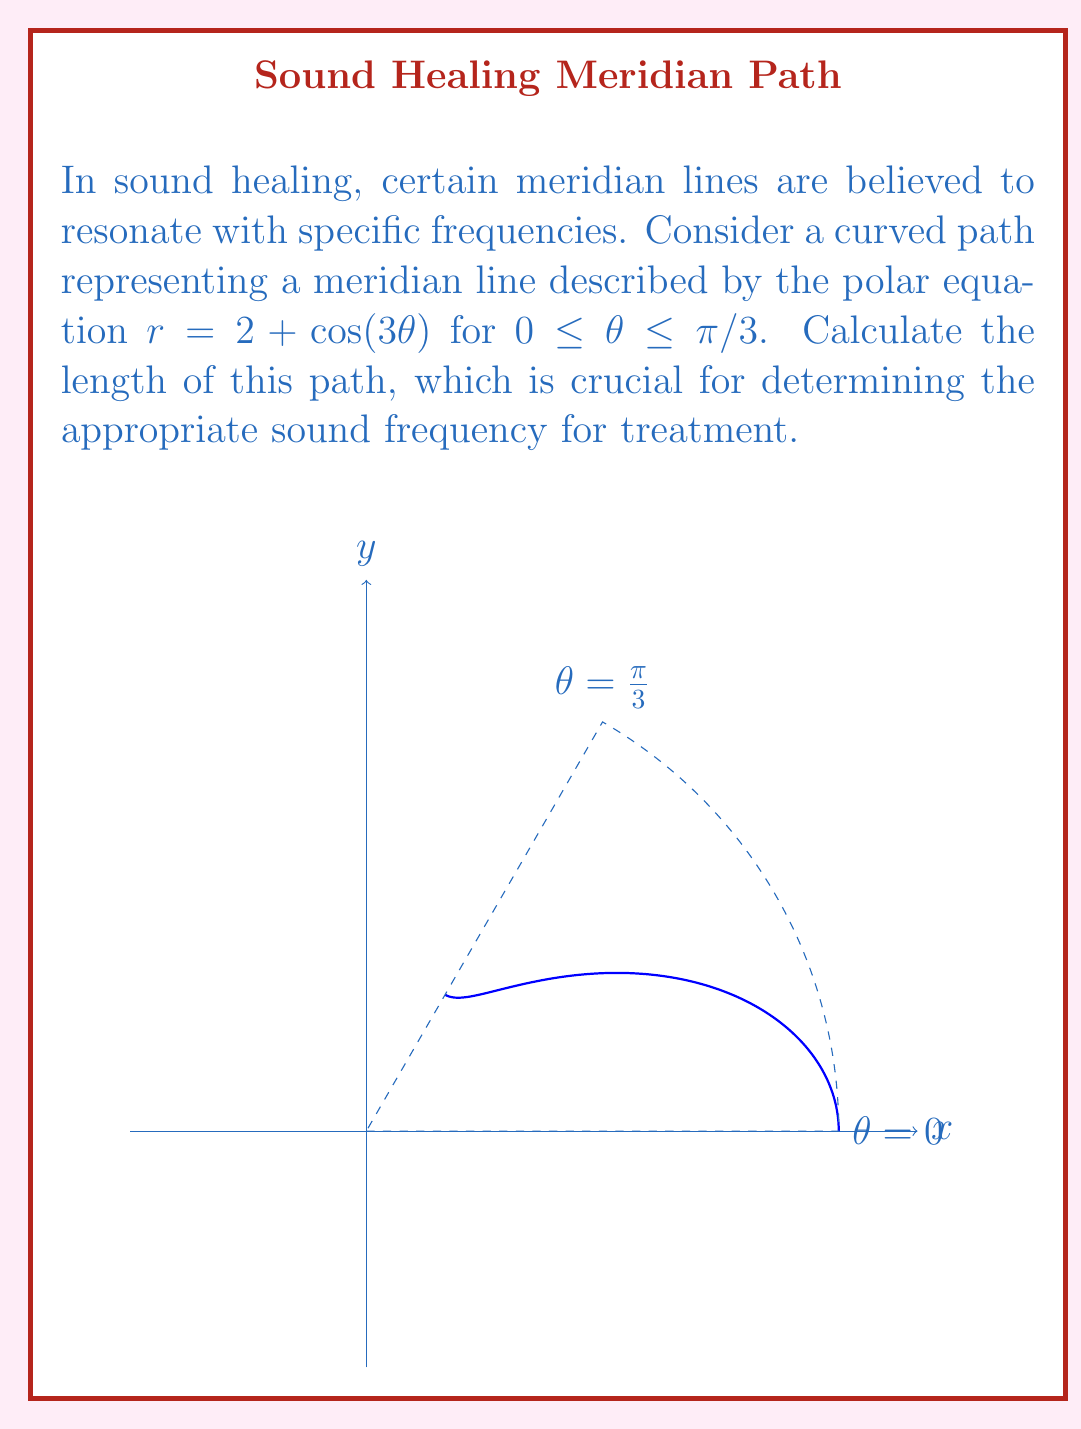Give your solution to this math problem. To find the length of the curved path, we'll use the formula for arc length in polar coordinates:

$$L = \int_a^b \sqrt{r^2 + \left(\frac{dr}{d\theta}\right)^2} d\theta$$

Step 1: Determine $r$ and $\frac{dr}{d\theta}$
$r = 2 + \cos(3\theta)$
$\frac{dr}{d\theta} = -3\sin(3\theta)$

Step 2: Substitute into the arc length formula
$$L = \int_0^{\pi/3} \sqrt{(2 + \cos(3\theta))^2 + (-3\sin(3\theta))^2} d\theta$$

Step 3: Simplify the integrand
$$L = \int_0^{\pi/3} \sqrt{4 + 4\cos(3\theta) + \cos^2(3\theta) + 9\sin^2(3\theta)} d\theta$$
$$L = \int_0^{\pi/3} \sqrt{4 + 4\cos(3\theta) + 1 + 8\sin^2(3\theta)} d\theta$$
$$L = \int_0^{\pi/3} \sqrt{5 + 4\cos(3\theta) + 8\sin^2(3\theta)} d\theta$$

Step 4: This integral cannot be evaluated analytically. We need to use numerical integration methods to approximate the result.

Using a numerical integration method (such as Simpson's rule or Gaussian quadrature), we can approximate the integral to be approximately 2.715 units.
Answer: $\approx 2.715$ units 